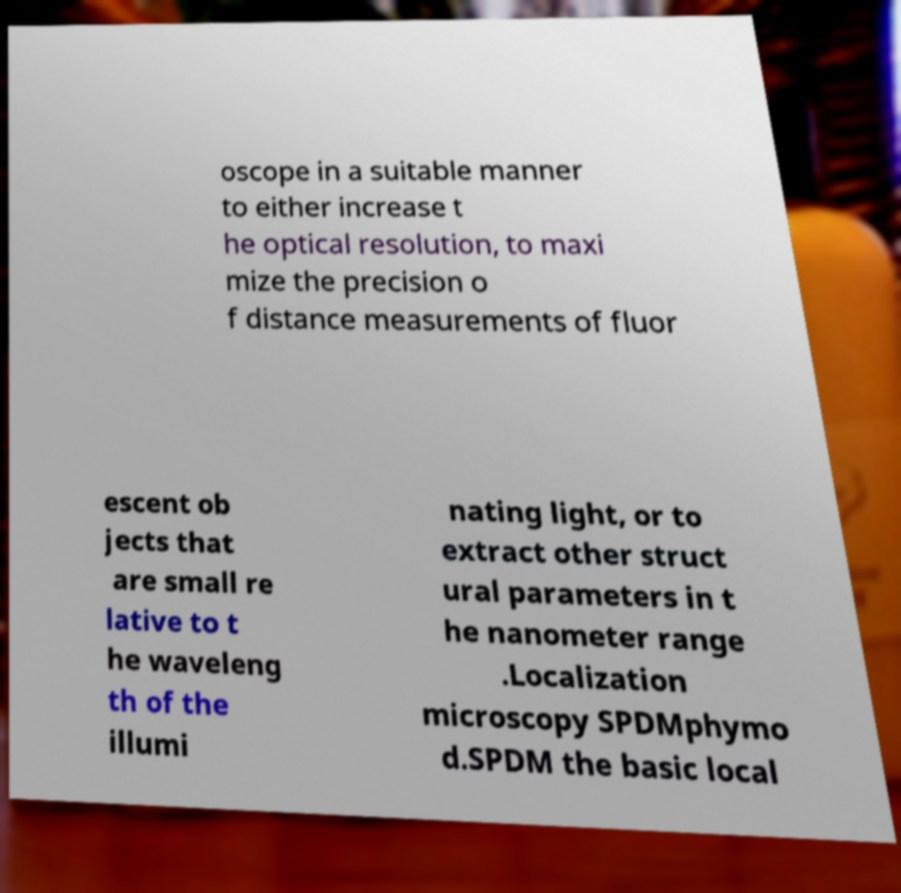Can you read and provide the text displayed in the image?This photo seems to have some interesting text. Can you extract and type it out for me? oscope in a suitable manner to either increase t he optical resolution, to maxi mize the precision o f distance measurements of fluor escent ob jects that are small re lative to t he waveleng th of the illumi nating light, or to extract other struct ural parameters in t he nanometer range .Localization microscopy SPDMphymo d.SPDM the basic local 